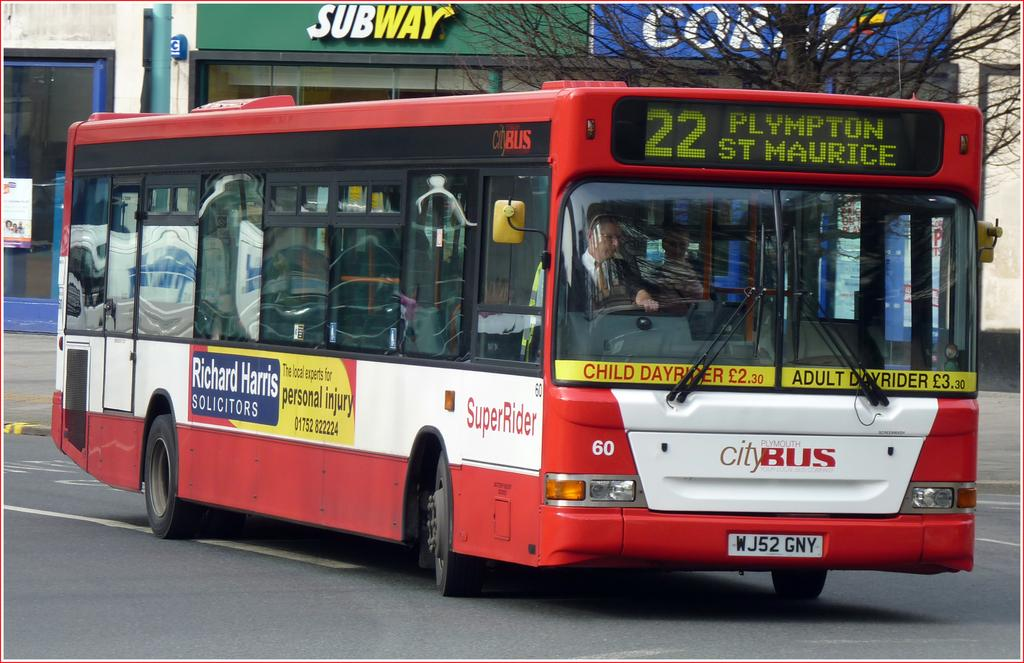What is the main subject of the image? There is a bus in the center of the image. Where is the bus located? The bus is on the road. What can be seen in the background of the image? There are buildings and a tree in the background of the image. How many dimes are scattered on the road next to the bus in the image? There are no dimes visible in the image; it only shows a bus on the road with buildings and a tree in the background. 